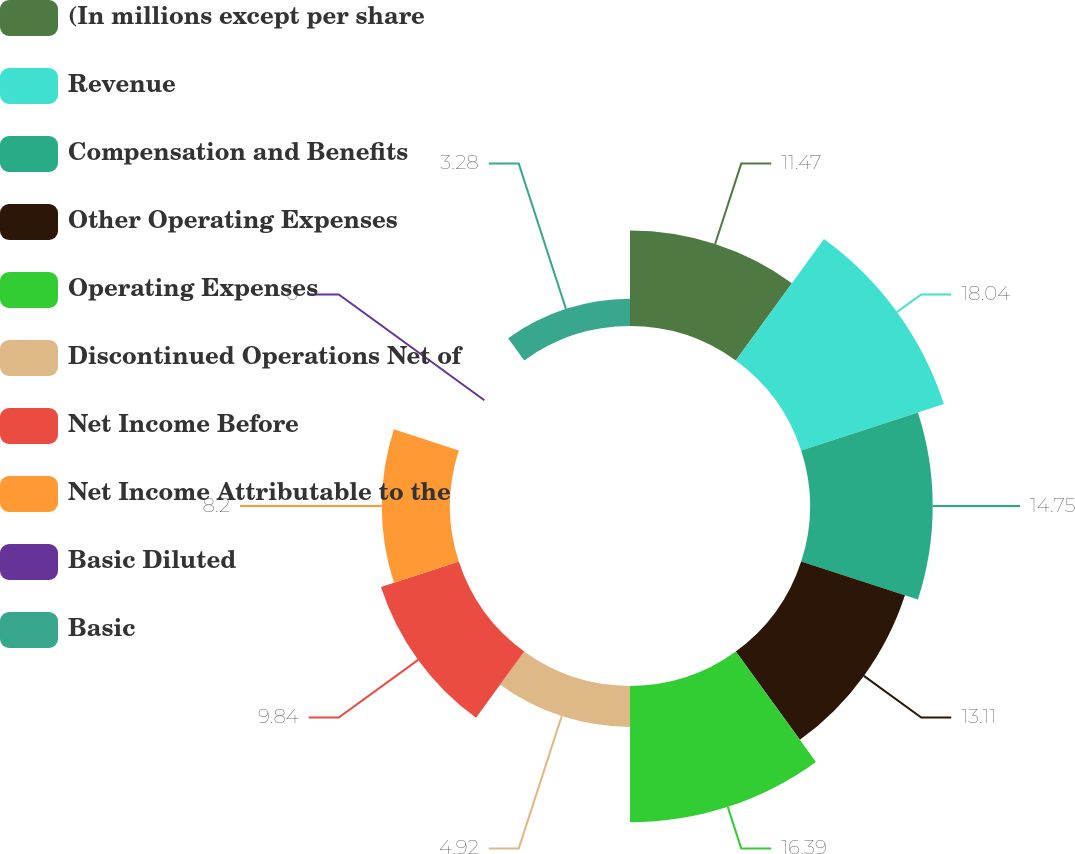Convert chart to OTSL. <chart><loc_0><loc_0><loc_500><loc_500><pie_chart><fcel>(In millions except per share<fcel>Revenue<fcel>Compensation and Benefits<fcel>Other Operating Expenses<fcel>Operating Expenses<fcel>Discontinued Operations Net of<fcel>Net Income Before<fcel>Net Income Attributable to the<fcel>Basic Diluted<fcel>Basic<nl><fcel>11.47%<fcel>18.03%<fcel>14.75%<fcel>13.11%<fcel>16.39%<fcel>4.92%<fcel>9.84%<fcel>8.2%<fcel>0.0%<fcel>3.28%<nl></chart> 